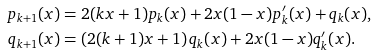Convert formula to latex. <formula><loc_0><loc_0><loc_500><loc_500>p _ { k + 1 } ( x ) & = 2 ( k x + 1 ) p _ { k } ( x ) + 2 x ( 1 - x ) p ^ { \prime } _ { k } ( x ) + q _ { k } ( x ) , \\ q _ { k + 1 } ( x ) & = \left ( 2 ( k + 1 ) x + 1 \right ) q _ { k } ( x ) + 2 x ( 1 - x ) q ^ { \prime } _ { k } ( x ) .</formula> 